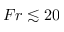<formula> <loc_0><loc_0><loc_500><loc_500>F r \lesssim 2 0</formula> 